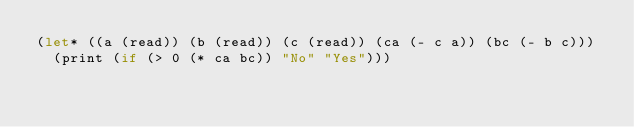Convert code to text. <code><loc_0><loc_0><loc_500><loc_500><_Scheme_>(let* ((a (read)) (b (read)) (c (read)) (ca (- c a)) (bc (- b c)))
  (print (if (> 0 (* ca bc)) "No" "Yes")))</code> 